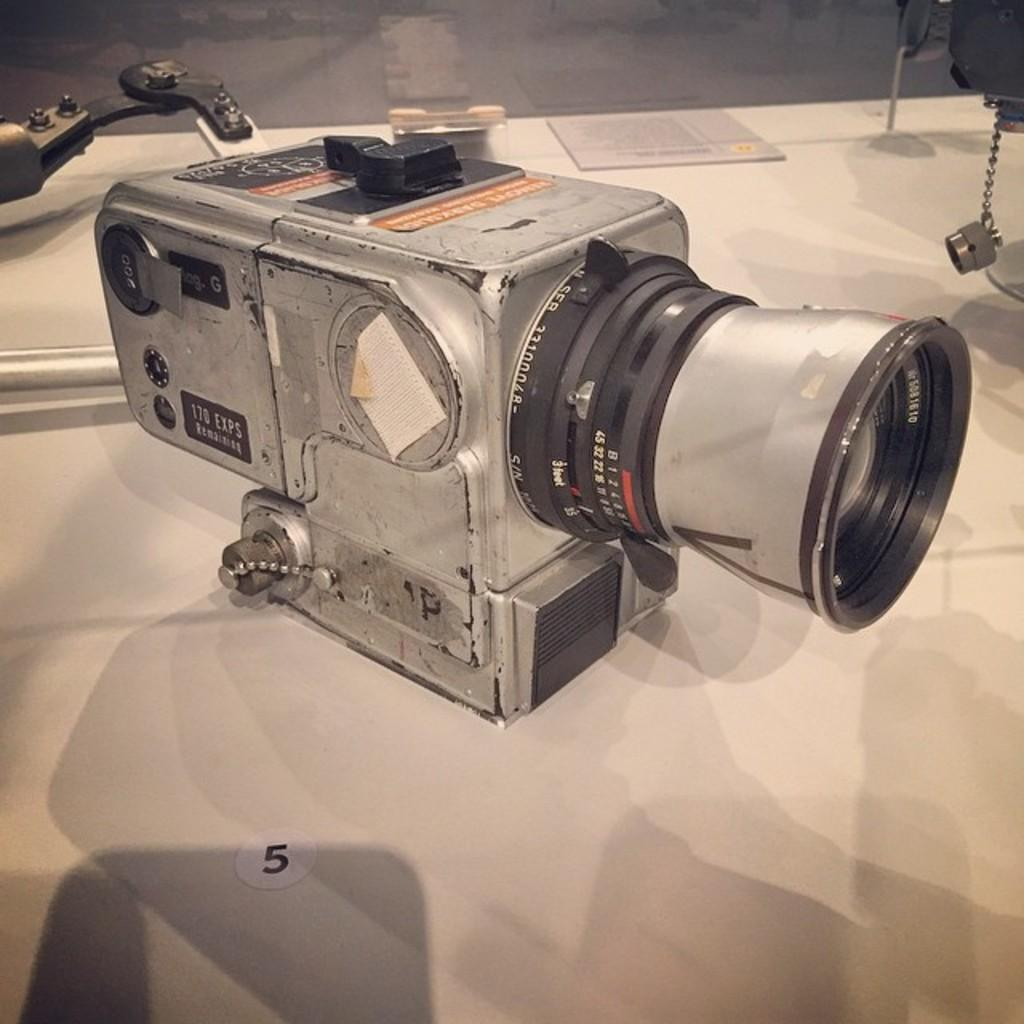What type of device is visible in the image? There is a digital camera in the image. What other object can be seen in the image? There is a book in the image. Where are these objects located? Both objects are on a table. What type of guitar is being played in the image? There is no guitar present in the image; it features a digital camera and a book on a table. 